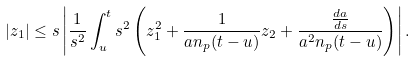Convert formula to latex. <formula><loc_0><loc_0><loc_500><loc_500>| z _ { 1 } | \leq s \left | \frac { 1 } { s ^ { 2 } } \int _ { u } ^ { t } s ^ { 2 } \left ( z _ { 1 } ^ { 2 } + \frac { 1 } { a n _ { p } ( t - u ) } z _ { 2 } + \frac { { \frac { d a } { d s } } } { a ^ { 2 } n _ { p } ( t - u ) } \right ) \right | .</formula> 